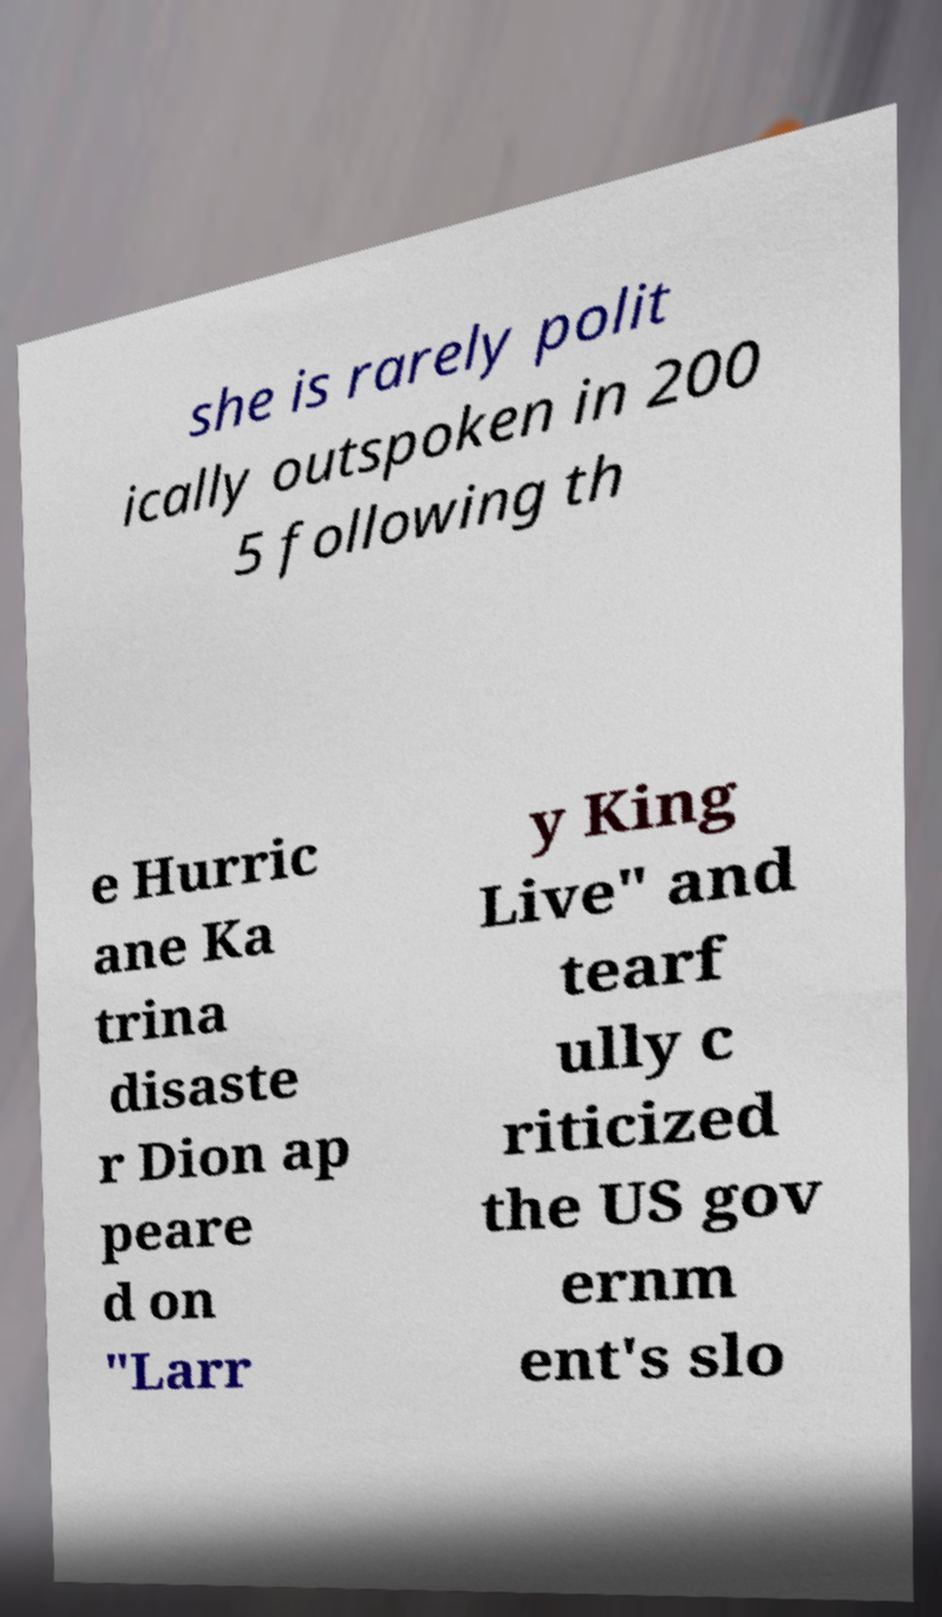Could you assist in decoding the text presented in this image and type it out clearly? she is rarely polit ically outspoken in 200 5 following th e Hurric ane Ka trina disaste r Dion ap peare d on "Larr y King Live" and tearf ully c riticized the US gov ernm ent's slo 